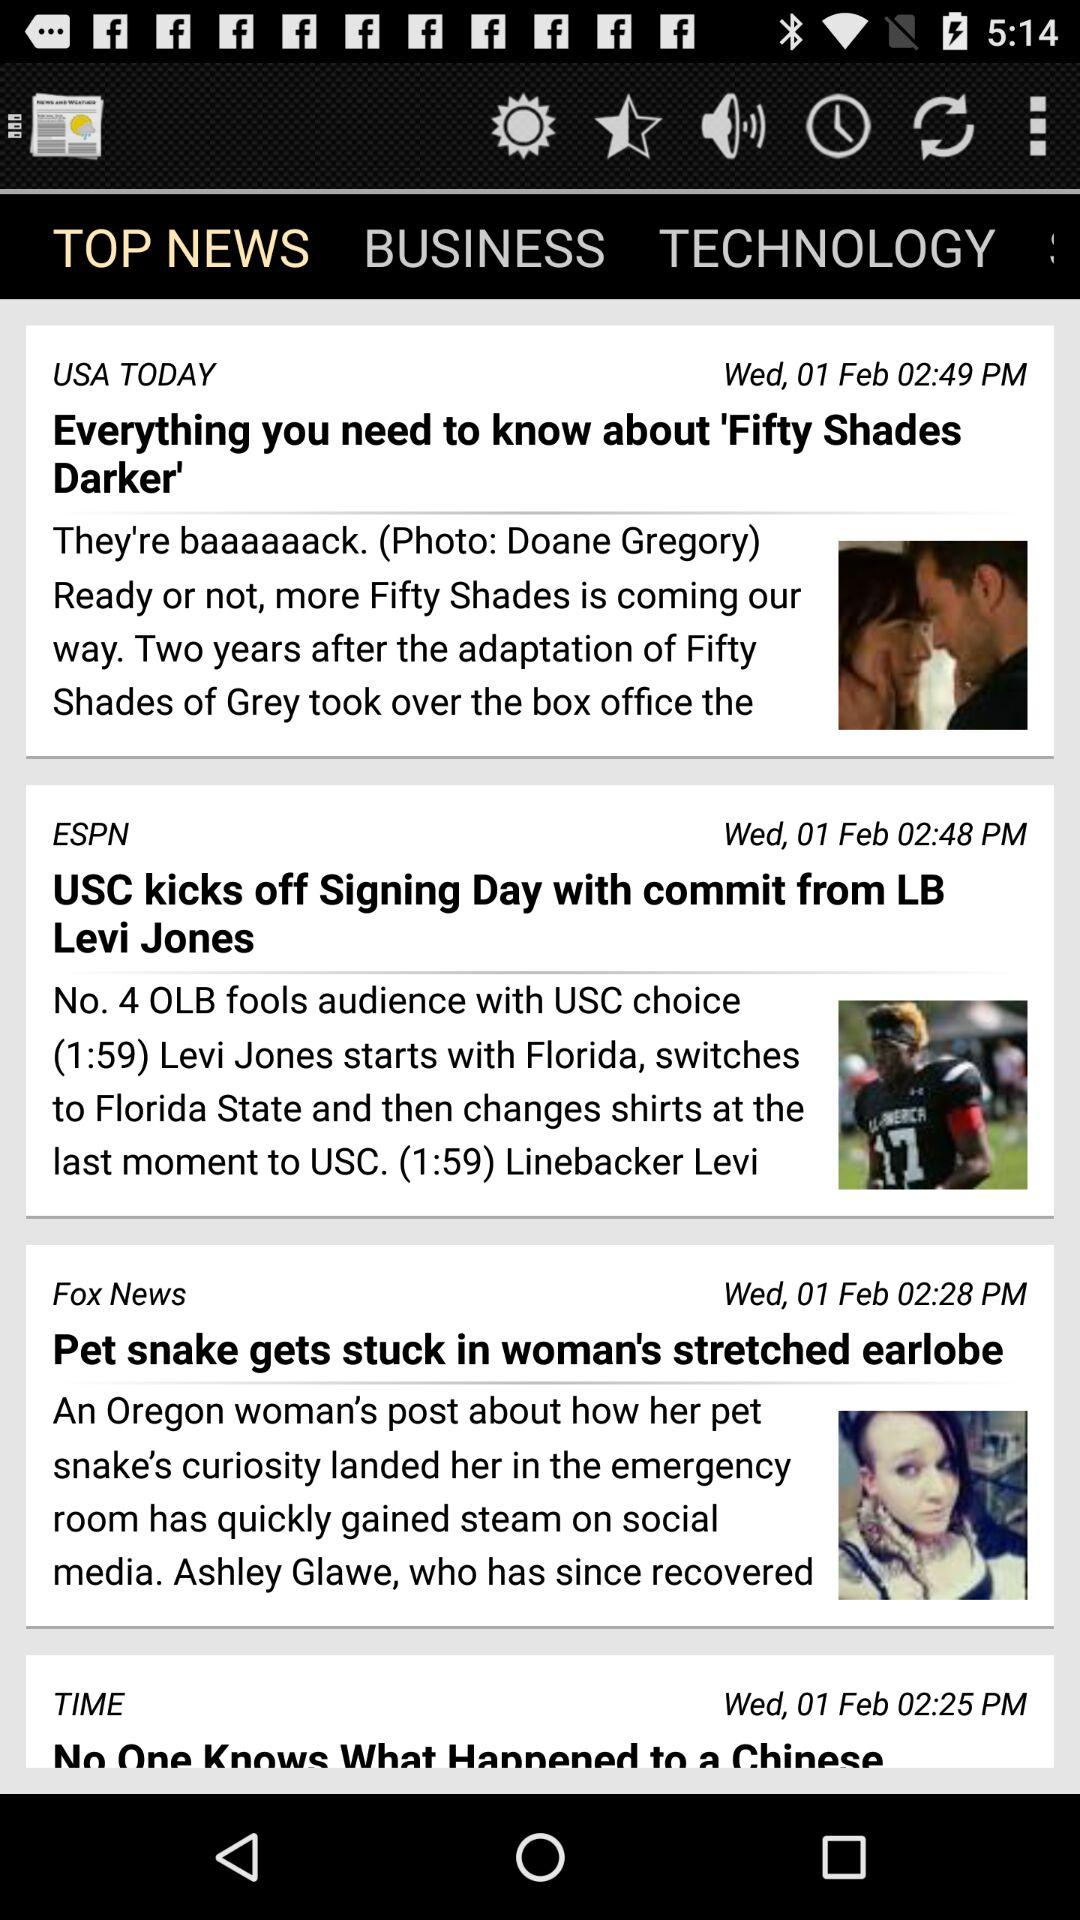What news was posted at 02:49 pm? The news posted at 02:49 pm was "Everything you need to know about 'Fifty Shades Darker'". 